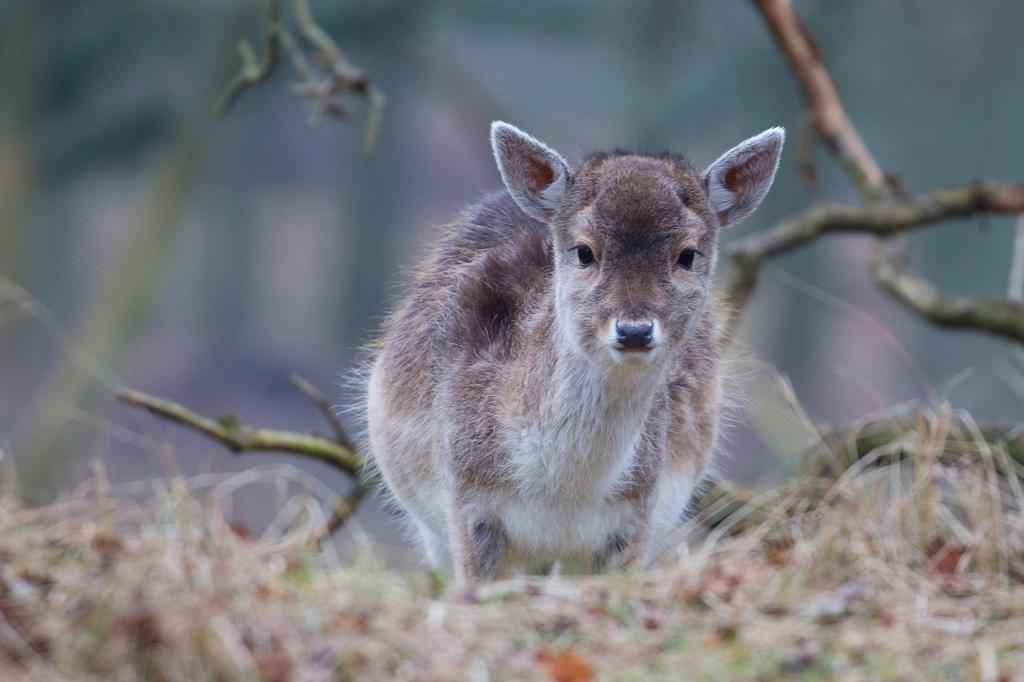What type of animal is in the image? There is an animal in the image, but its specific type cannot be determined from the provided facts. What colors can be seen on the animal? The animal has white, black, and brown colors. What is the animal standing on? The animal is standing on the grass. What else can be seen in the image besides the animal? There are stems visible in the image. How would you describe the background of the image? The background of the image is blurred. What book is the animal reading in the image? There is no book or reading activity present in the image. Can you tell me how much the animal's education costs based on the image? There is no information about the animal's education or its cost in the image. 